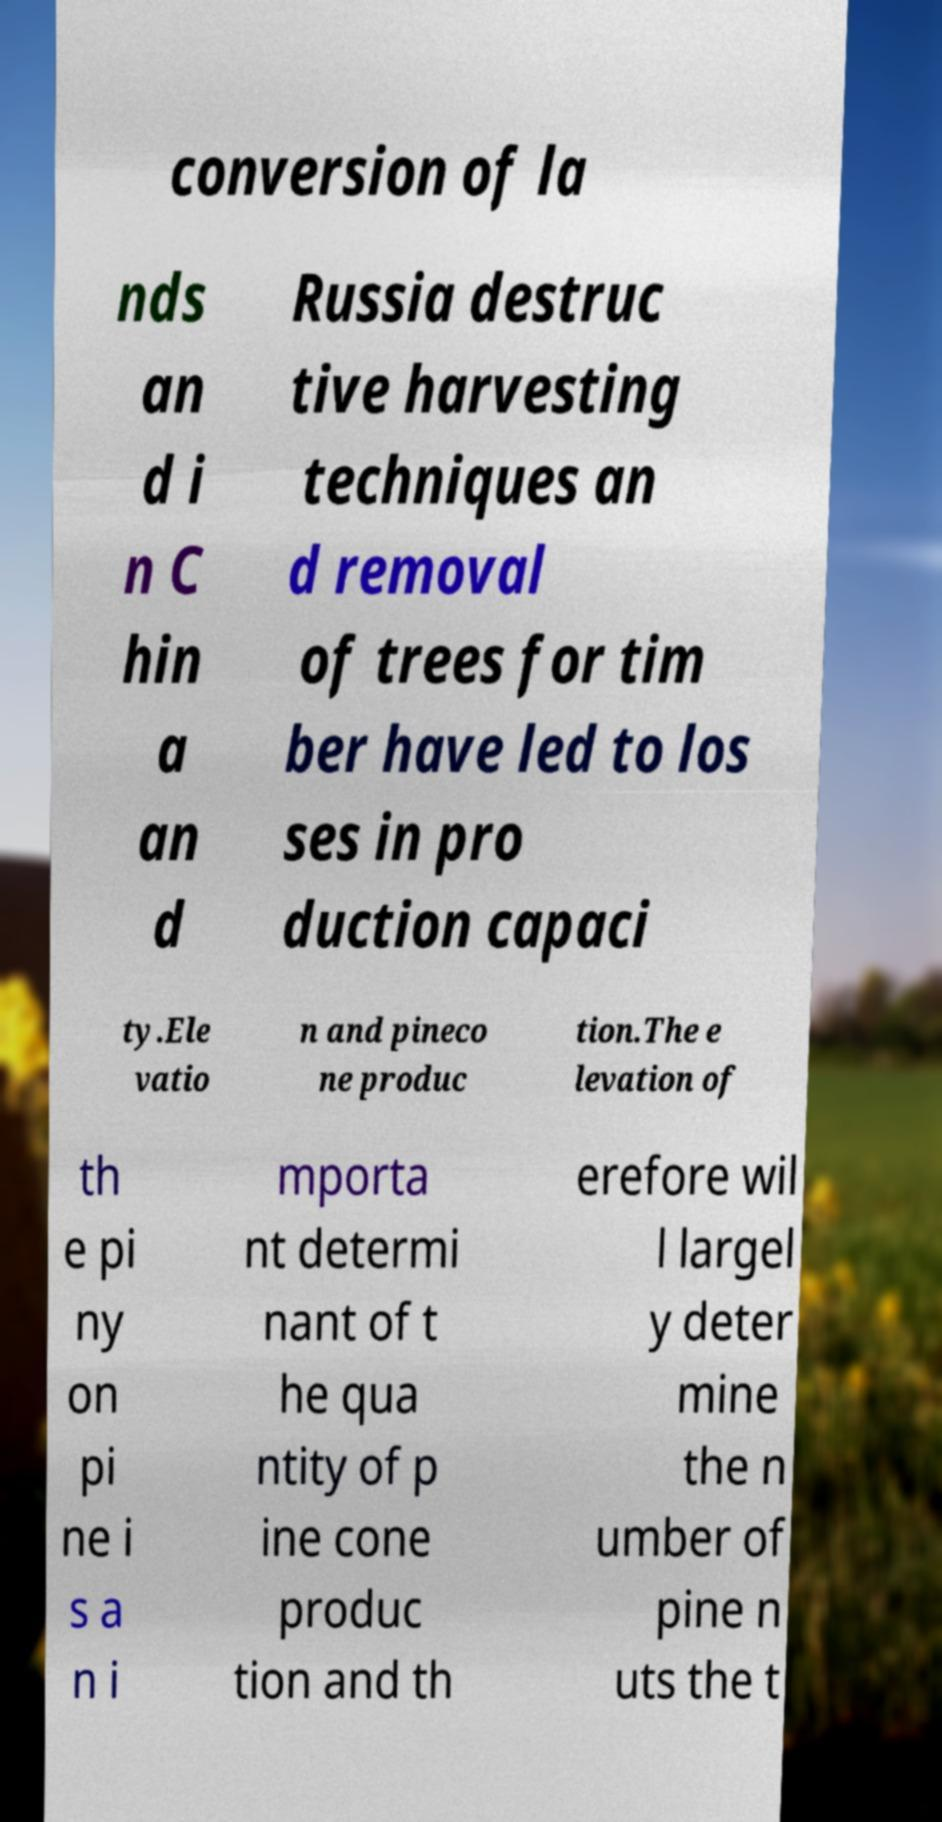Please read and relay the text visible in this image. What does it say? conversion of la nds an d i n C hin a an d Russia destruc tive harvesting techniques an d removal of trees for tim ber have led to los ses in pro duction capaci ty.Ele vatio n and pineco ne produc tion.The e levation of th e pi ny on pi ne i s a n i mporta nt determi nant of t he qua ntity of p ine cone produc tion and th erefore wil l largel y deter mine the n umber of pine n uts the t 